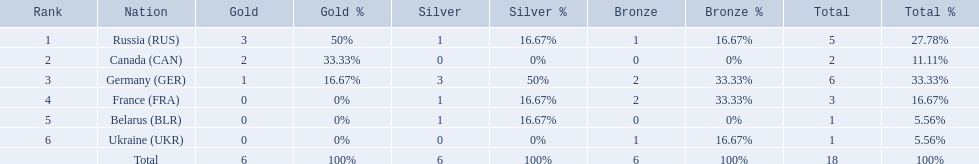What are all the countries in the 1994 winter olympics biathlon? Russia (RUS), Canada (CAN), Germany (GER), France (FRA), Belarus (BLR), Ukraine (UKR). Which of these received at least one gold medal? Russia (RUS), Canada (CAN), Germany (GER). Which of these received no silver or bronze medals? Canada (CAN). Which countries competed in the 1995 biathlon? Russia (RUS), Canada (CAN), Germany (GER), France (FRA), Belarus (BLR), Ukraine (UKR). How many medals in total did they win? 5, 2, 6, 3, 1, 1. And which country had the most? Germany (GER). 